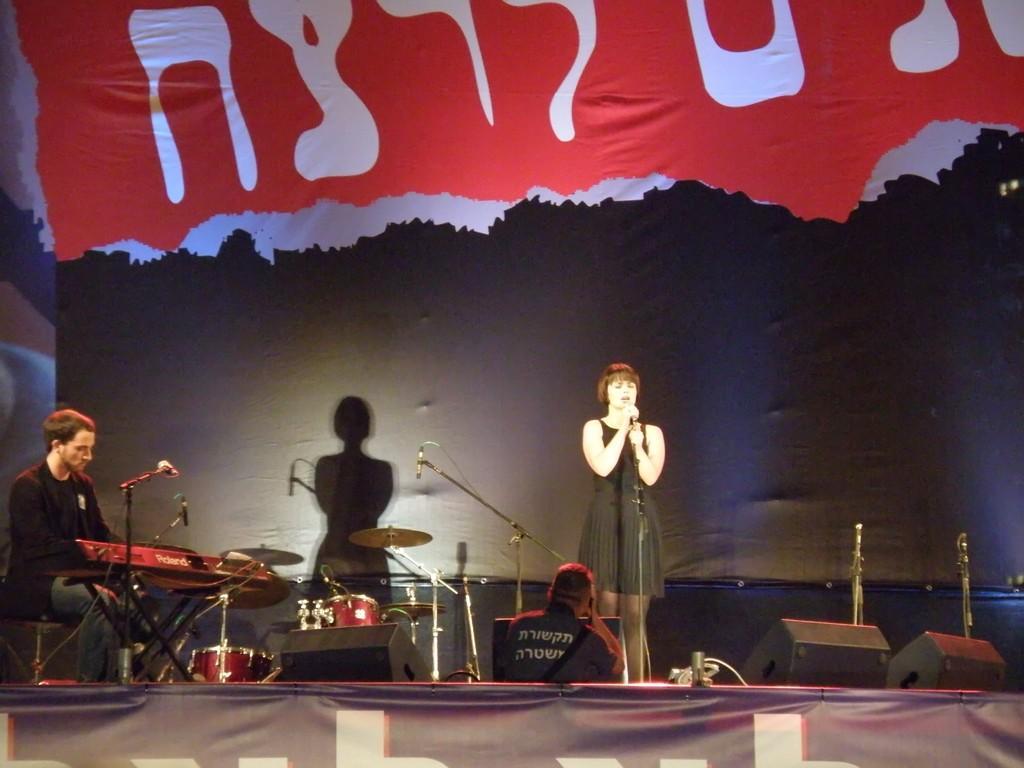In one or two sentences, can you explain what this image depicts? In the middle of this image I can see a woman wearing a black color dress, standing on the stage and holding a mike stand. On the left side a man is sitting and playing the piano. In the background there is a drum set and also I can see few black color boxes on the stage. At the bottom there is a banner. Behind this a person is standing. In the background there is a black color board. 